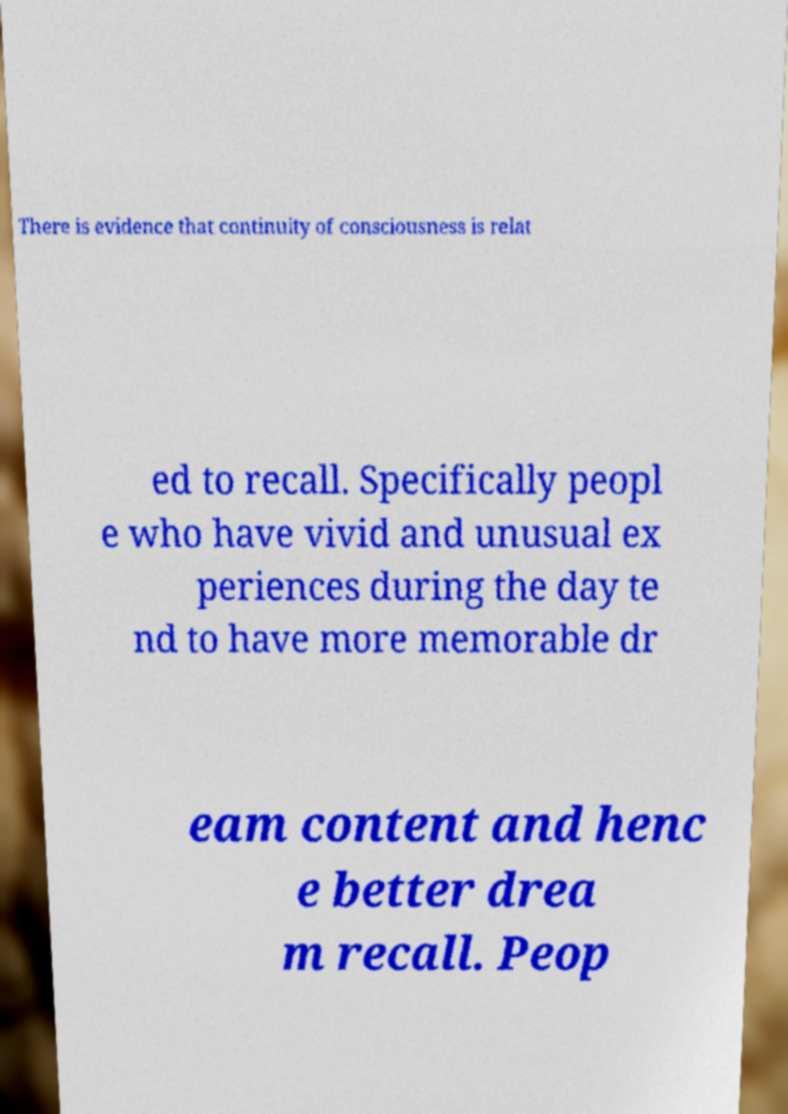There's text embedded in this image that I need extracted. Can you transcribe it verbatim? There is evidence that continuity of consciousness is relat ed to recall. Specifically peopl e who have vivid and unusual ex periences during the day te nd to have more memorable dr eam content and henc e better drea m recall. Peop 